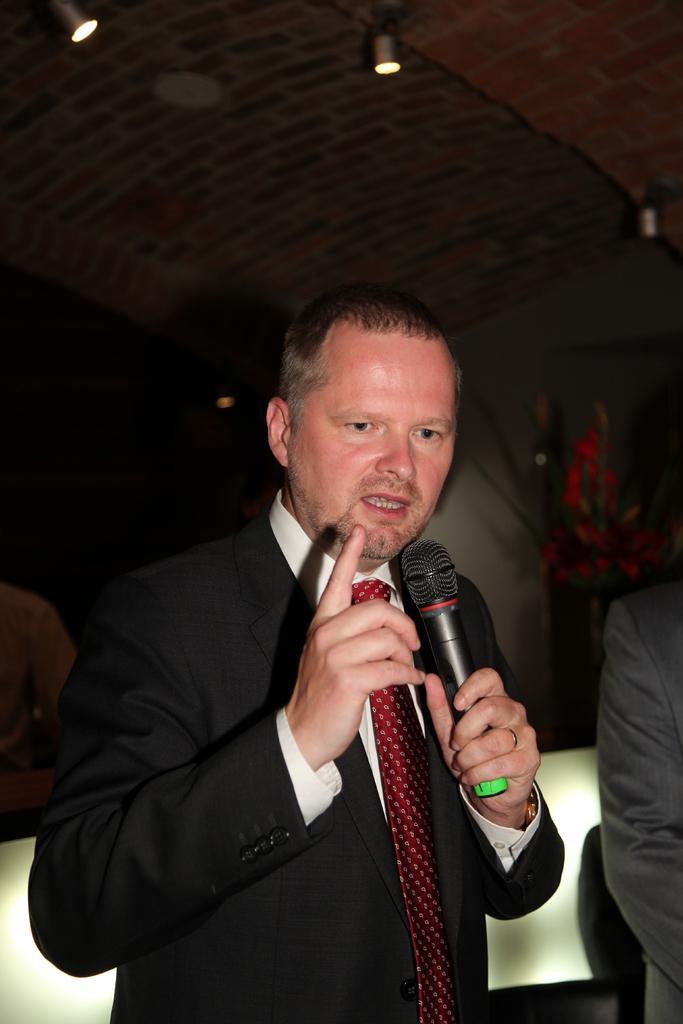Could you give a brief overview of what you see in this image? This person standing and holding microphone and talking. On the background we can see wall,house plant. On the top we can see lights. 